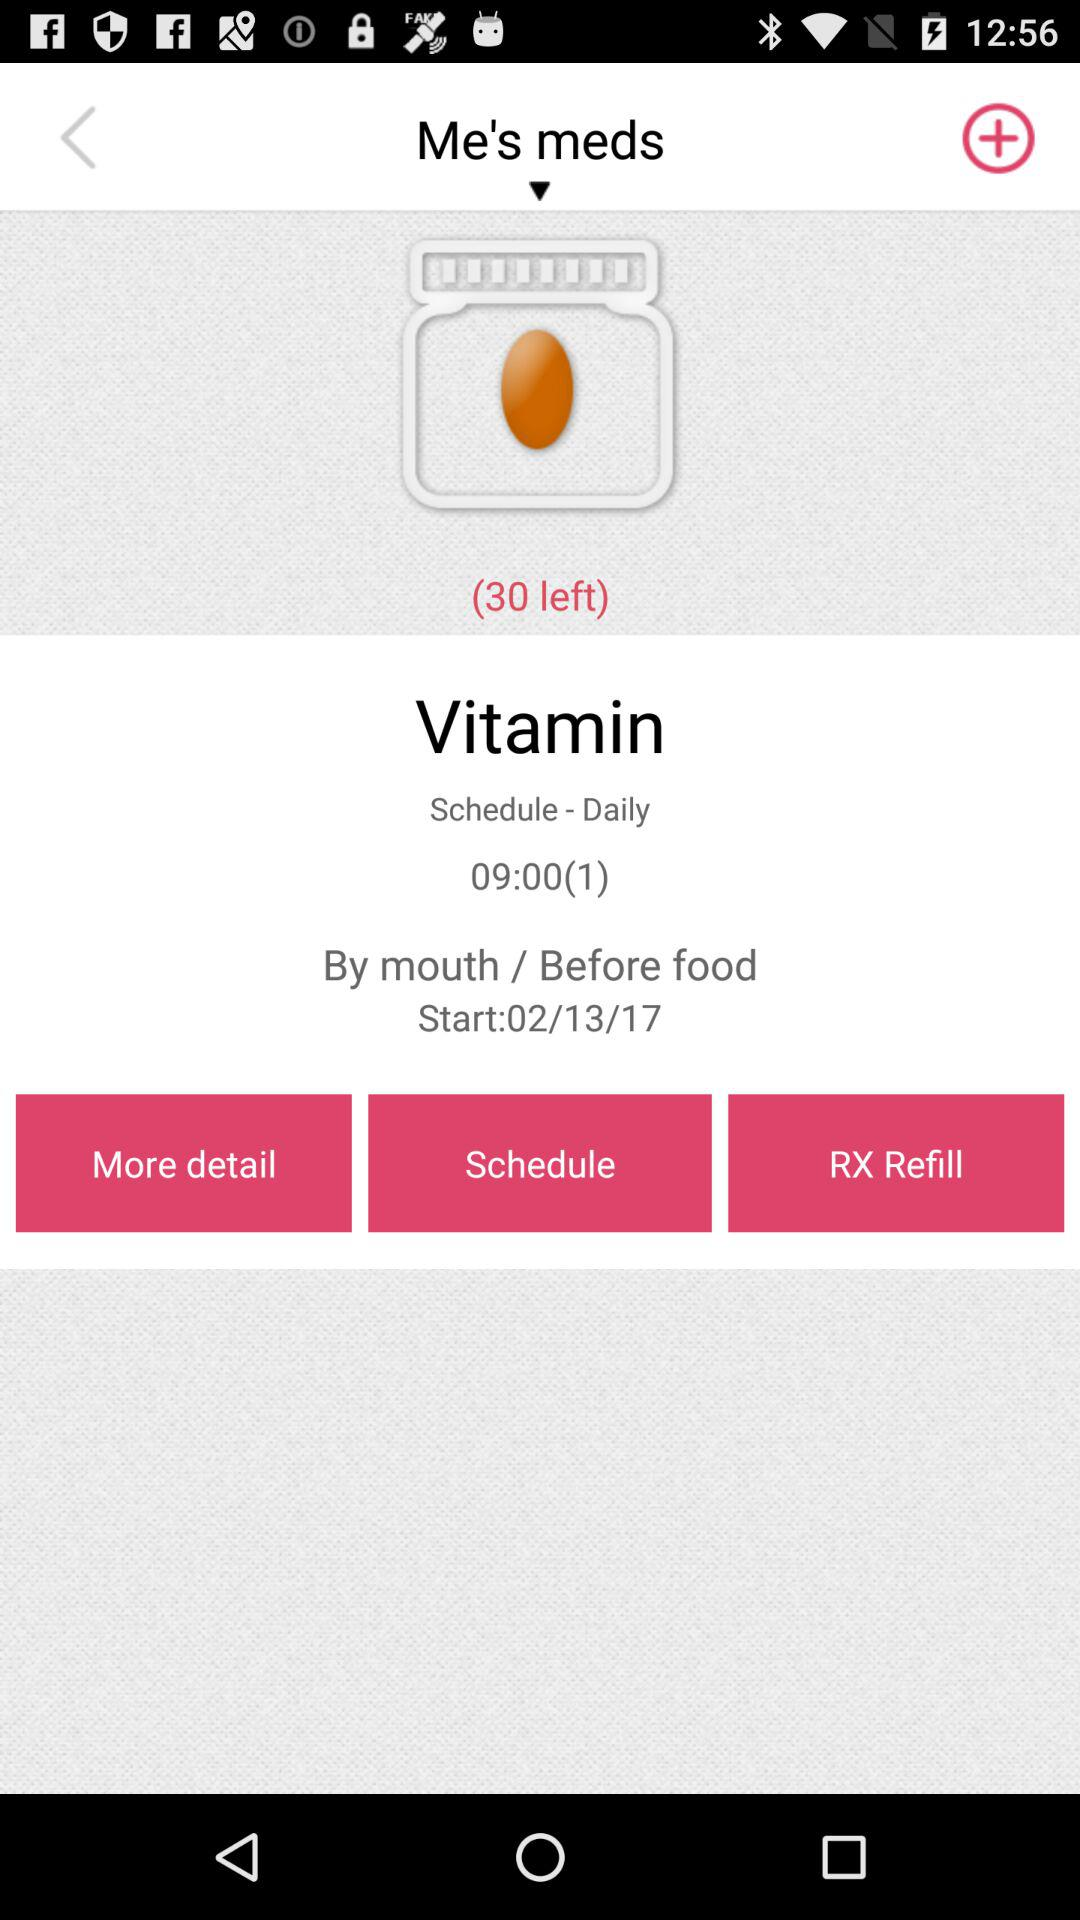How many pills are left for this medication?
Answer the question using a single word or phrase. 30 